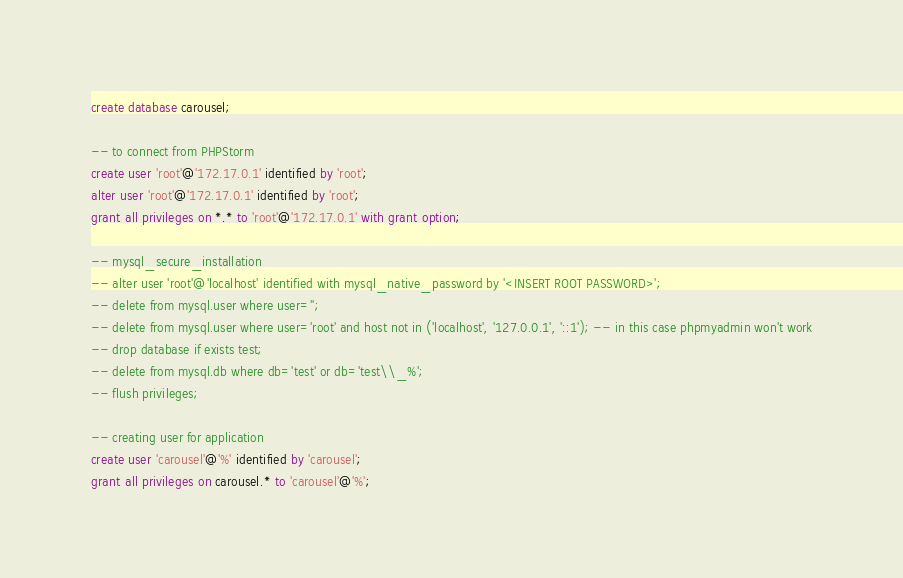<code> <loc_0><loc_0><loc_500><loc_500><_SQL_>create database carousel;

-- to connect from PHPStorm
create user 'root'@'172.17.0.1' identified by 'root';
alter user 'root'@'172.17.0.1' identified by 'root';
grant all privileges on *.* to 'root'@'172.17.0.1' with grant option;

-- mysql_secure_installation
-- alter user 'root'@'localhost' identified with mysql_native_password by '<INSERT ROOT PASSWORD>';
-- delete from mysql.user where user='';
-- delete from mysql.user where user='root' and host not in ('localhost', '127.0.0.1', '::1'); -- in this case phpmyadmin won't work
-- drop database if exists test;
-- delete from mysql.db where db='test' or db='test\\_%';
-- flush privileges;

-- creating user for application
create user 'carousel'@'%' identified by 'carousel';
grant all privileges on carousel.* to 'carousel'@'%';</code> 